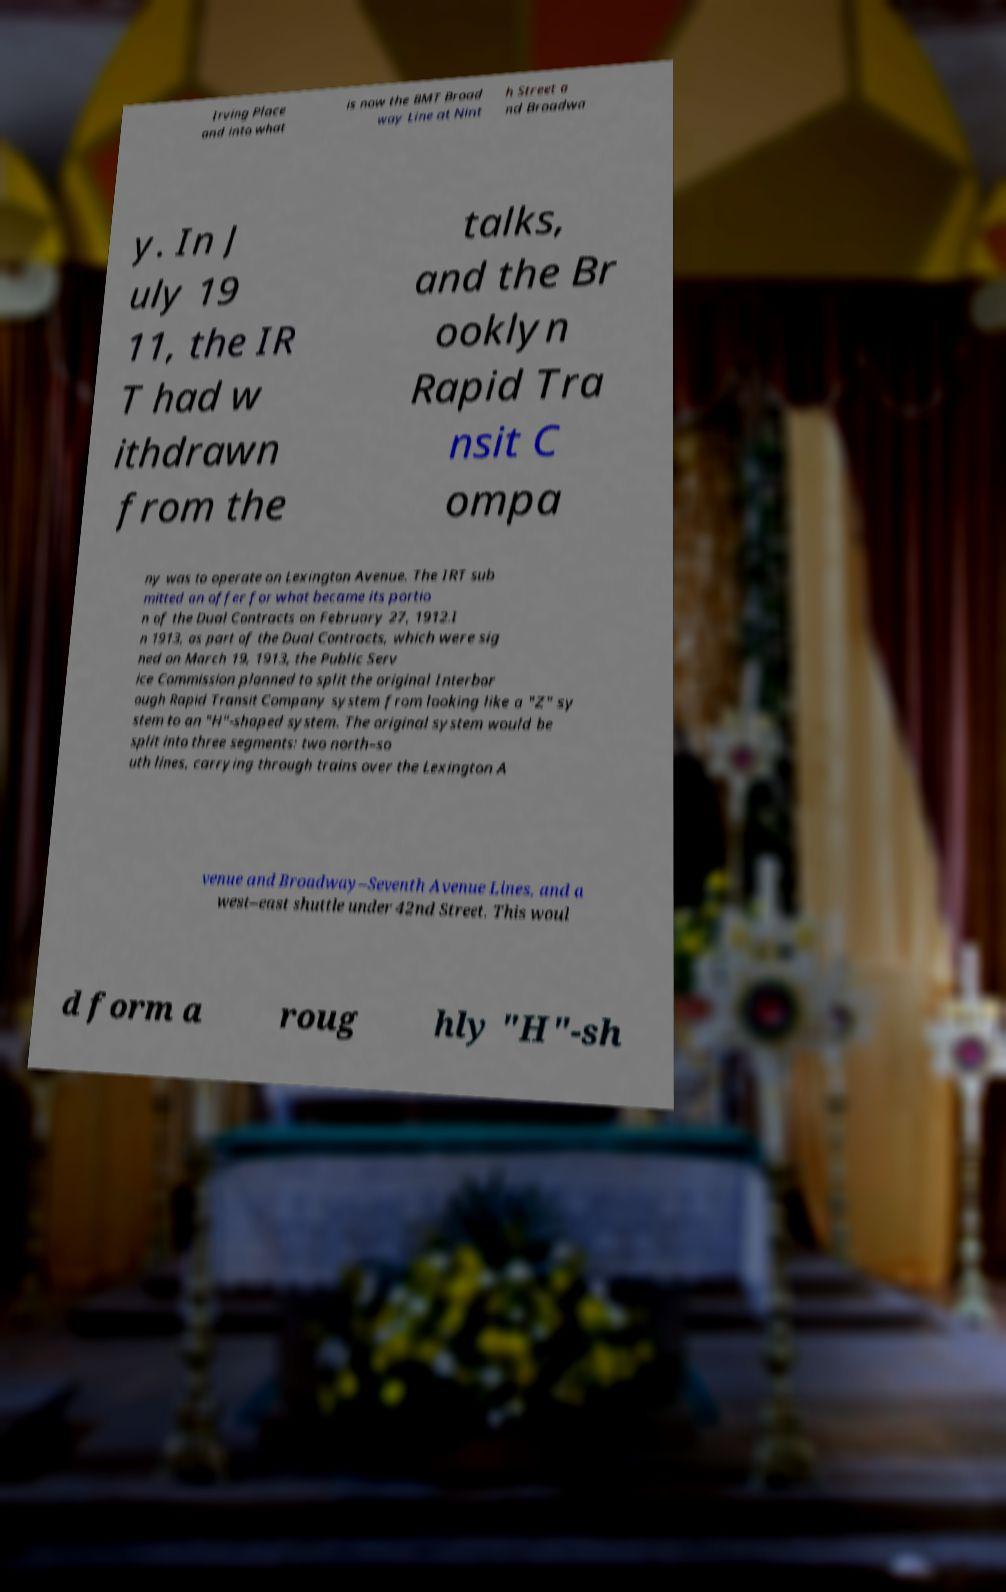Please identify and transcribe the text found in this image. Irving Place and into what is now the BMT Broad way Line at Nint h Street a nd Broadwa y. In J uly 19 11, the IR T had w ithdrawn from the talks, and the Br ooklyn Rapid Tra nsit C ompa ny was to operate on Lexington Avenue. The IRT sub mitted an offer for what became its portio n of the Dual Contracts on February 27, 1912.I n 1913, as part of the Dual Contracts, which were sig ned on March 19, 1913, the Public Serv ice Commission planned to split the original Interbor ough Rapid Transit Company system from looking like a "Z" sy stem to an "H"-shaped system. The original system would be split into three segments: two north–so uth lines, carrying through trains over the Lexington A venue and Broadway–Seventh Avenue Lines, and a west–east shuttle under 42nd Street. This woul d form a roug hly "H"-sh 